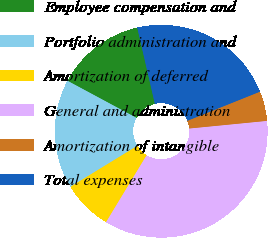Convert chart to OTSL. <chart><loc_0><loc_0><loc_500><loc_500><pie_chart><fcel>Employee compensation and<fcel>Portfolio administration and<fcel>Amortization of deferred<fcel>General and administration<fcel>Amortization of intangible<fcel>Total expenses<nl><fcel>13.53%<fcel>16.6%<fcel>7.58%<fcel>35.23%<fcel>4.51%<fcel>22.55%<nl></chart> 